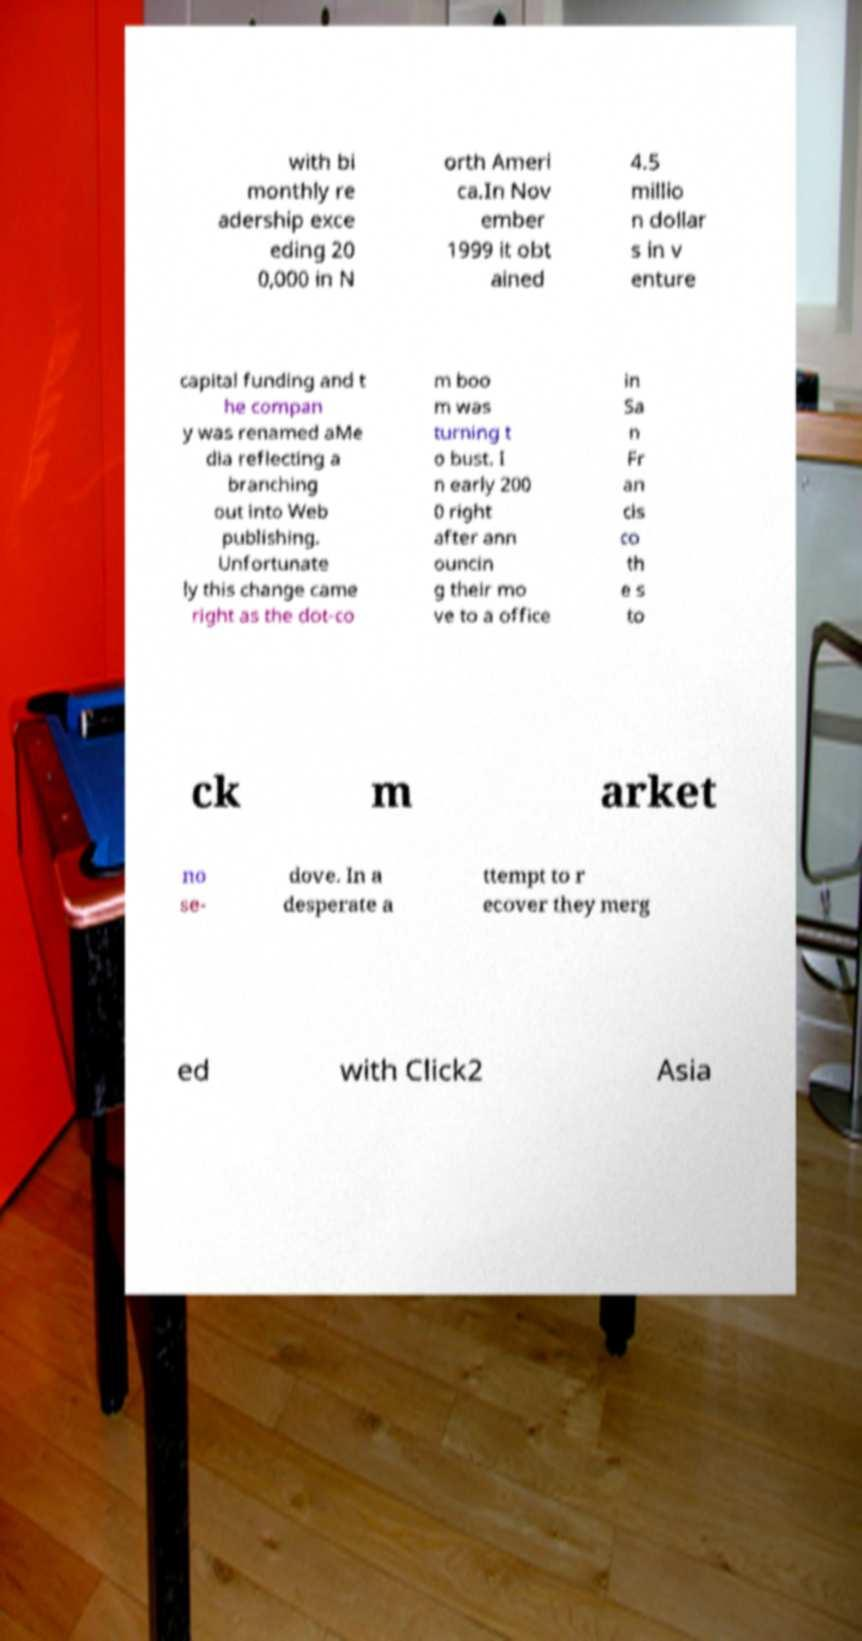Could you extract and type out the text from this image? with bi monthly re adership exce eding 20 0,000 in N orth Ameri ca.In Nov ember 1999 it obt ained 4.5 millio n dollar s in v enture capital funding and t he compan y was renamed aMe dia reflecting a branching out into Web publishing. Unfortunate ly this change came right as the dot-co m boo m was turning t o bust. I n early 200 0 right after ann ouncin g their mo ve to a office in Sa n Fr an cis co th e s to ck m arket no se- dove. In a desperate a ttempt to r ecover they merg ed with Click2 Asia 